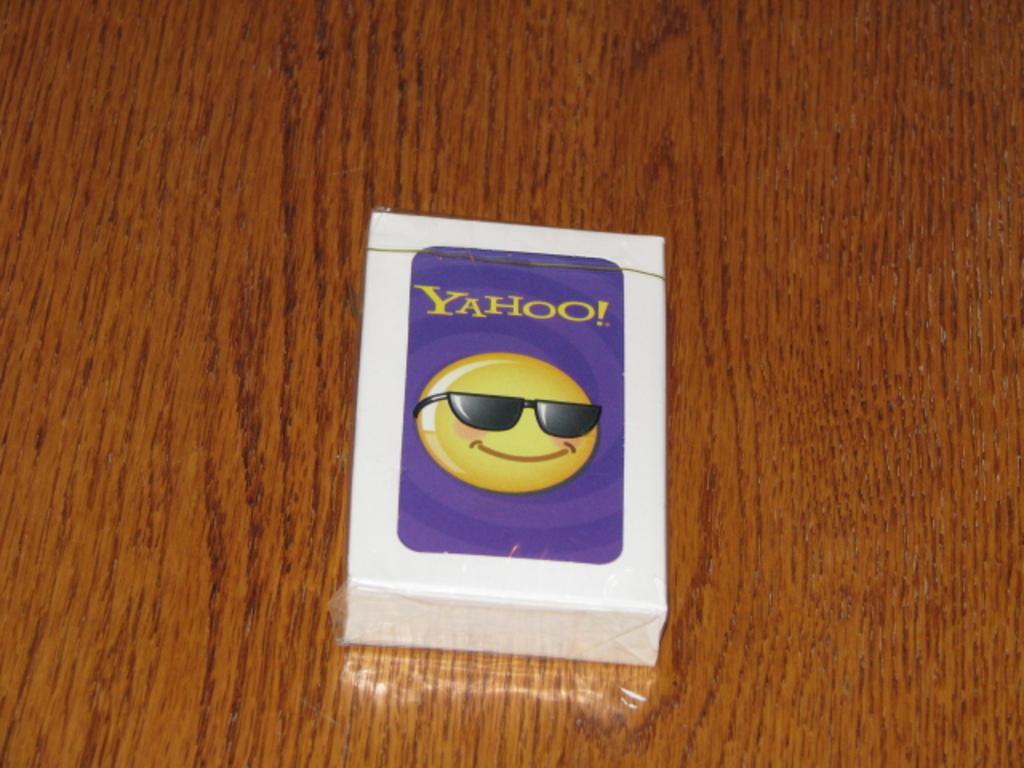In one or two sentences, can you explain what this image depicts? In the center of the picture there is a box, on the box there is an emoticon and text. The box is placed on a wooden object. 